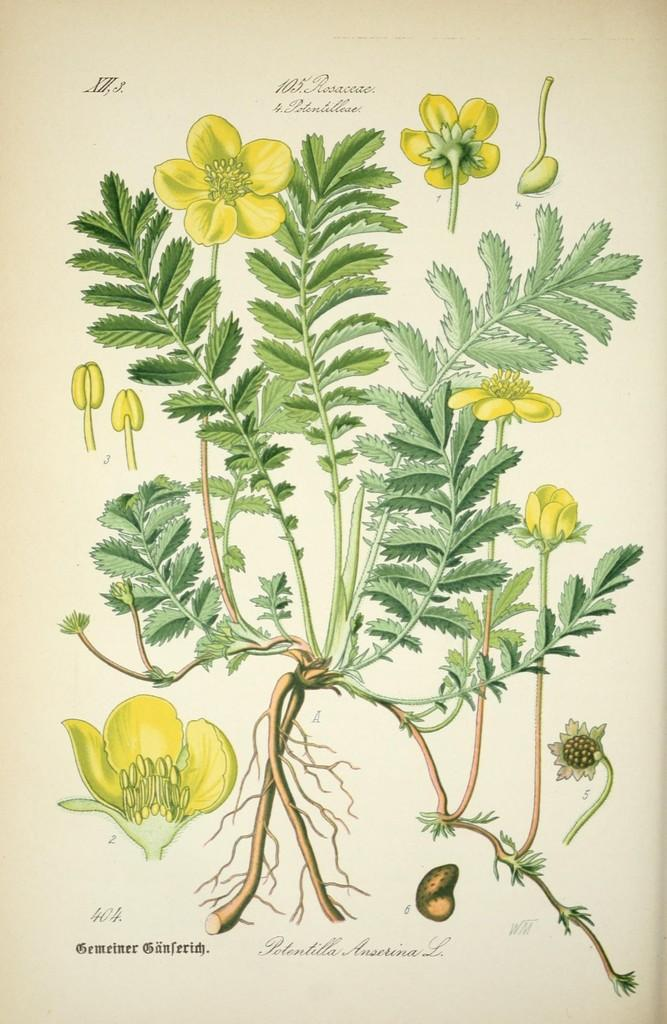What is depicted in the image? There is a picture of a plant in the image. What specific features can be observed on the plant? The plant has a group of flowers and roots. Is there any text associated with the image? Yes, there is some text associated with the image. What verse can be heard being recited by the plant in the image? There is no verse being recited by the plant in the image, as plants do not have the ability to speak or recite verses. 